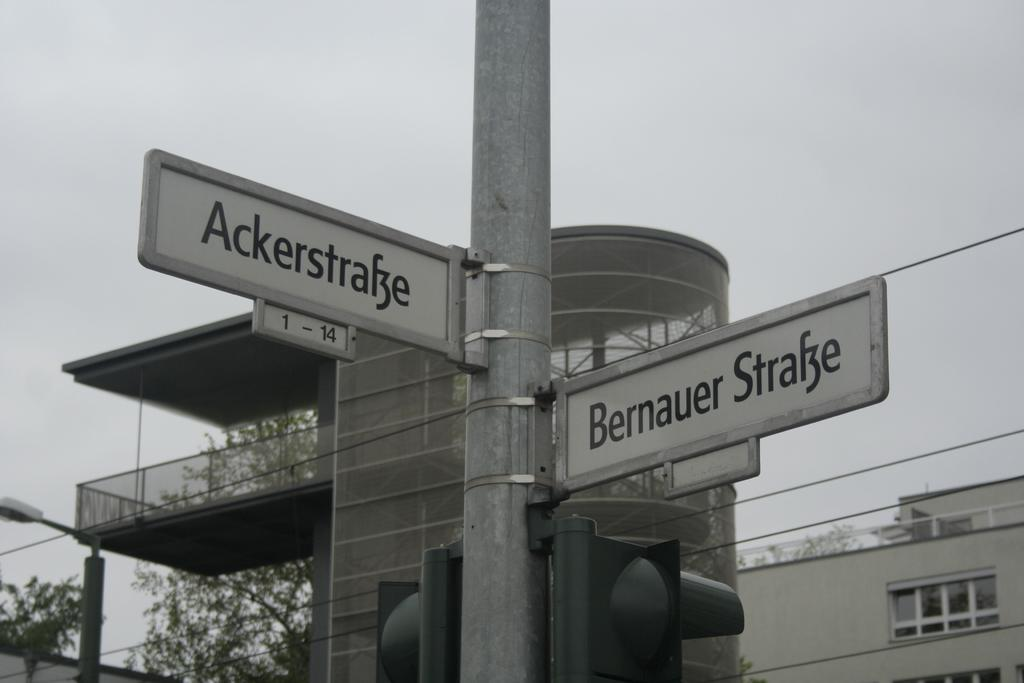<image>
Render a clear and concise summary of the photo. A street name sign showing the intersection of Ackerstrafze and Bernauer Strafze. 